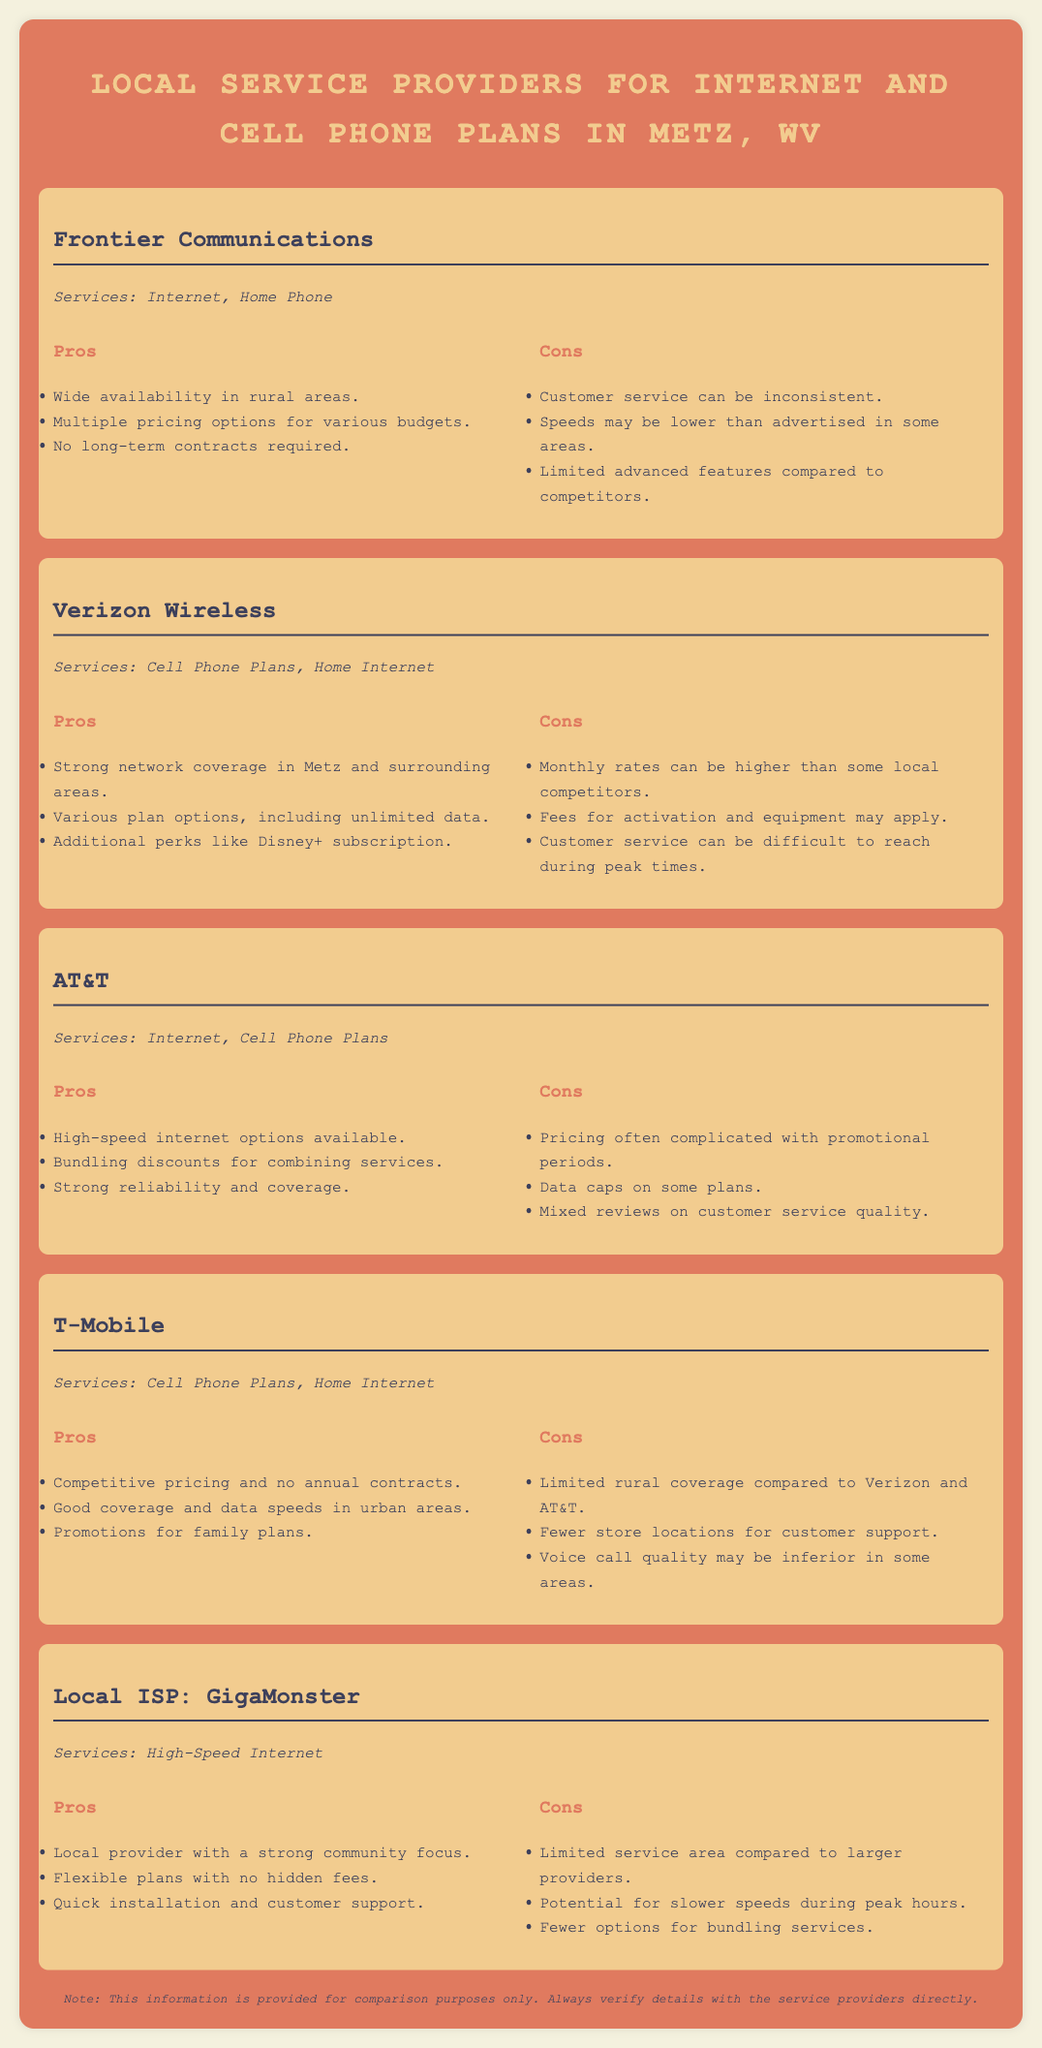What services does Frontier Communications offer? The services offered by Frontier Communications as stated in the document are Internet and Home Phone.
Answer: Internet, Home Phone What is a pro of choosing Verizon Wireless? A pro of choosing Verizon Wireless is that it has strong network coverage in Metz and surrounding areas.
Answer: Strong network coverage What is a con of AT&T? A con of AT&T mentioned in the document is that pricing often complicated with promotional periods.
Answer: Complicated pricing What unique service does GigaMonster provide? GigaMonster provides High-Speed Internet as its unique service.
Answer: High-Speed Internet Which provider has no annual contracts? T-Mobile is noted for having competitive pricing and no annual contracts.
Answer: T-Mobile What additional perk does Verizon Wireless offer? Verizon Wireless offers an additional perk of a Disney+ subscription.
Answer: Disney+ subscription Which provider focuses on community support? GigaMonster is highlighted as a local provider with a strong community focus.
Answer: GigaMonster Which provider has limited rural coverage? T-Mobile is noted to have limited rural coverage compared to Verizon and AT&T.
Answer: T-Mobile How many pros does AT&T have listed in the document? The document lists three pros for AT&T.
Answer: Three pros 